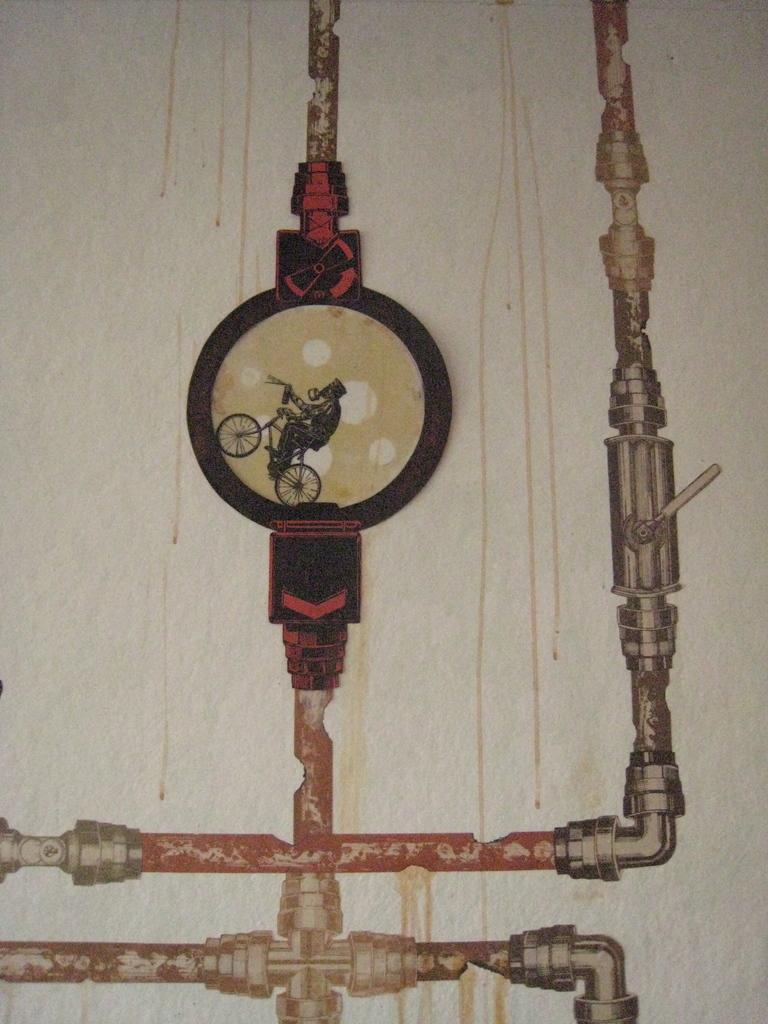What type of artwork is depicted in the image? The image appears to be a painting. Who or what is the main subject of the painting? There is a man in the painting. What is the man doing in the painting? The man is riding a cycle. How many legs does the chair have in the painting? There is no chair present in the painting; the man is riding a cycle. 